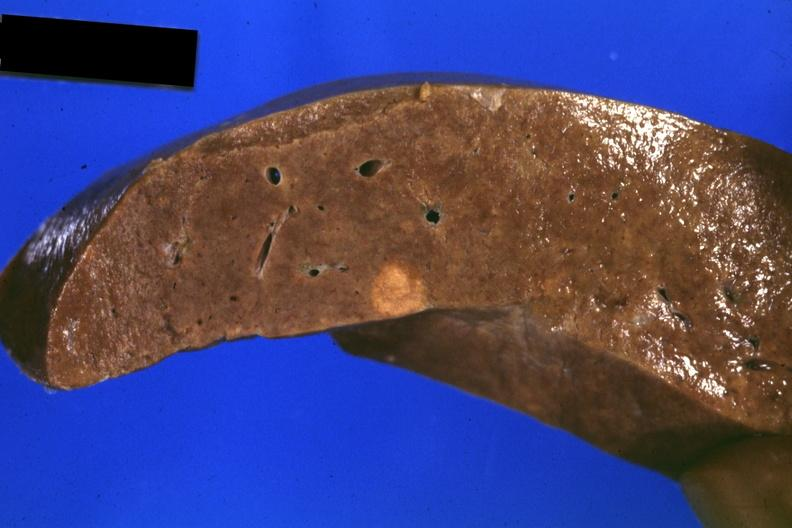what does this image show?
Answer the question using a single word or phrase. Fixed tissue close-up of tumor mass in liver 